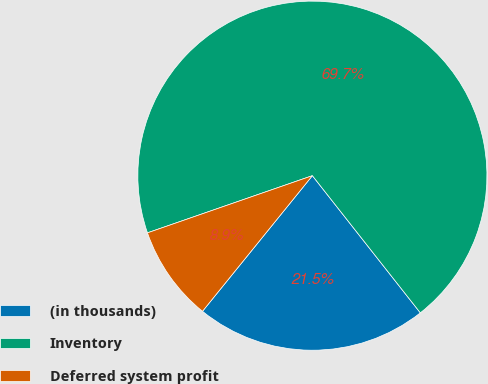Convert chart. <chart><loc_0><loc_0><loc_500><loc_500><pie_chart><fcel>(in thousands)<fcel>Inventory<fcel>Deferred system profit<nl><fcel>21.45%<fcel>69.7%<fcel>8.85%<nl></chart> 